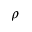Convert formula to latex. <formula><loc_0><loc_0><loc_500><loc_500>\rho</formula> 